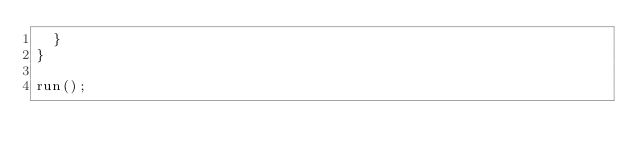Convert code to text. <code><loc_0><loc_0><loc_500><loc_500><_JavaScript_>  }
}

run();
</code> 